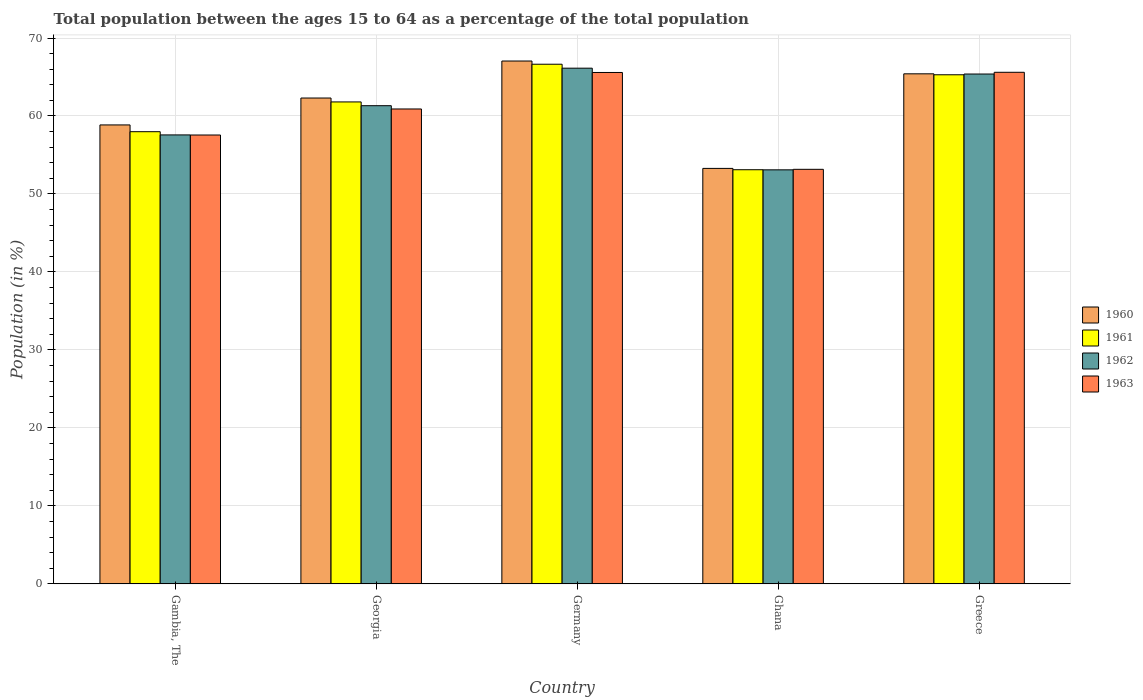How many groups of bars are there?
Your answer should be very brief. 5. How many bars are there on the 2nd tick from the left?
Offer a very short reply. 4. How many bars are there on the 3rd tick from the right?
Provide a short and direct response. 4. What is the label of the 1st group of bars from the left?
Make the answer very short. Gambia, The. In how many cases, is the number of bars for a given country not equal to the number of legend labels?
Give a very brief answer. 0. What is the percentage of the population ages 15 to 64 in 1963 in Greece?
Give a very brief answer. 65.61. Across all countries, what is the maximum percentage of the population ages 15 to 64 in 1963?
Make the answer very short. 65.61. Across all countries, what is the minimum percentage of the population ages 15 to 64 in 1960?
Keep it short and to the point. 53.28. In which country was the percentage of the population ages 15 to 64 in 1962 minimum?
Keep it short and to the point. Ghana. What is the total percentage of the population ages 15 to 64 in 1963 in the graph?
Ensure brevity in your answer.  302.81. What is the difference between the percentage of the population ages 15 to 64 in 1962 in Ghana and that in Greece?
Your response must be concise. -12.29. What is the difference between the percentage of the population ages 15 to 64 in 1962 in Georgia and the percentage of the population ages 15 to 64 in 1963 in Germany?
Make the answer very short. -4.26. What is the average percentage of the population ages 15 to 64 in 1963 per country?
Keep it short and to the point. 60.56. What is the difference between the percentage of the population ages 15 to 64 of/in 1961 and percentage of the population ages 15 to 64 of/in 1963 in Greece?
Give a very brief answer. -0.32. In how many countries, is the percentage of the population ages 15 to 64 in 1962 greater than 48?
Your response must be concise. 5. What is the ratio of the percentage of the population ages 15 to 64 in 1960 in Ghana to that in Greece?
Keep it short and to the point. 0.81. Is the difference between the percentage of the population ages 15 to 64 in 1961 in Gambia, The and Greece greater than the difference between the percentage of the population ages 15 to 64 in 1963 in Gambia, The and Greece?
Provide a succinct answer. Yes. What is the difference between the highest and the second highest percentage of the population ages 15 to 64 in 1962?
Ensure brevity in your answer.  -0.75. What is the difference between the highest and the lowest percentage of the population ages 15 to 64 in 1960?
Your answer should be very brief. 13.77. Is it the case that in every country, the sum of the percentage of the population ages 15 to 64 in 1961 and percentage of the population ages 15 to 64 in 1960 is greater than the sum of percentage of the population ages 15 to 64 in 1963 and percentage of the population ages 15 to 64 in 1962?
Give a very brief answer. No. Are all the bars in the graph horizontal?
Offer a terse response. No. What is the difference between two consecutive major ticks on the Y-axis?
Give a very brief answer. 10. Does the graph contain any zero values?
Your response must be concise. No. Does the graph contain grids?
Provide a short and direct response. Yes. How are the legend labels stacked?
Your response must be concise. Vertical. What is the title of the graph?
Ensure brevity in your answer.  Total population between the ages 15 to 64 as a percentage of the total population. What is the Population (in %) in 1960 in Gambia, The?
Give a very brief answer. 58.86. What is the Population (in %) of 1961 in Gambia, The?
Your answer should be very brief. 57.99. What is the Population (in %) of 1962 in Gambia, The?
Your answer should be compact. 57.57. What is the Population (in %) in 1963 in Gambia, The?
Keep it short and to the point. 57.56. What is the Population (in %) of 1960 in Georgia?
Ensure brevity in your answer.  62.31. What is the Population (in %) of 1961 in Georgia?
Your answer should be compact. 61.8. What is the Population (in %) in 1962 in Georgia?
Your answer should be compact. 61.32. What is the Population (in %) of 1963 in Georgia?
Offer a very short reply. 60.9. What is the Population (in %) in 1960 in Germany?
Make the answer very short. 67.05. What is the Population (in %) of 1961 in Germany?
Keep it short and to the point. 66.64. What is the Population (in %) in 1962 in Germany?
Your response must be concise. 66.13. What is the Population (in %) in 1963 in Germany?
Offer a very short reply. 65.58. What is the Population (in %) of 1960 in Ghana?
Offer a very short reply. 53.28. What is the Population (in %) in 1961 in Ghana?
Offer a very short reply. 53.11. What is the Population (in %) of 1962 in Ghana?
Ensure brevity in your answer.  53.1. What is the Population (in %) in 1963 in Ghana?
Offer a terse response. 53.16. What is the Population (in %) of 1960 in Greece?
Provide a short and direct response. 65.41. What is the Population (in %) in 1961 in Greece?
Ensure brevity in your answer.  65.29. What is the Population (in %) in 1962 in Greece?
Offer a terse response. 65.38. What is the Population (in %) of 1963 in Greece?
Keep it short and to the point. 65.61. Across all countries, what is the maximum Population (in %) of 1960?
Make the answer very short. 67.05. Across all countries, what is the maximum Population (in %) of 1961?
Keep it short and to the point. 66.64. Across all countries, what is the maximum Population (in %) of 1962?
Keep it short and to the point. 66.13. Across all countries, what is the maximum Population (in %) of 1963?
Your answer should be very brief. 65.61. Across all countries, what is the minimum Population (in %) of 1960?
Give a very brief answer. 53.28. Across all countries, what is the minimum Population (in %) in 1961?
Ensure brevity in your answer.  53.11. Across all countries, what is the minimum Population (in %) in 1962?
Offer a terse response. 53.1. Across all countries, what is the minimum Population (in %) in 1963?
Provide a short and direct response. 53.16. What is the total Population (in %) in 1960 in the graph?
Offer a very short reply. 306.9. What is the total Population (in %) in 1961 in the graph?
Offer a terse response. 304.83. What is the total Population (in %) in 1962 in the graph?
Keep it short and to the point. 303.51. What is the total Population (in %) in 1963 in the graph?
Your answer should be compact. 302.81. What is the difference between the Population (in %) in 1960 in Gambia, The and that in Georgia?
Offer a very short reply. -3.45. What is the difference between the Population (in %) of 1961 in Gambia, The and that in Georgia?
Your answer should be very brief. -3.82. What is the difference between the Population (in %) in 1962 in Gambia, The and that in Georgia?
Make the answer very short. -3.75. What is the difference between the Population (in %) in 1963 in Gambia, The and that in Georgia?
Your answer should be compact. -3.34. What is the difference between the Population (in %) of 1960 in Gambia, The and that in Germany?
Keep it short and to the point. -8.2. What is the difference between the Population (in %) of 1961 in Gambia, The and that in Germany?
Provide a succinct answer. -8.65. What is the difference between the Population (in %) in 1962 in Gambia, The and that in Germany?
Make the answer very short. -8.56. What is the difference between the Population (in %) in 1963 in Gambia, The and that in Germany?
Provide a succinct answer. -8.02. What is the difference between the Population (in %) in 1960 in Gambia, The and that in Ghana?
Provide a succinct answer. 5.58. What is the difference between the Population (in %) in 1961 in Gambia, The and that in Ghana?
Your response must be concise. 4.88. What is the difference between the Population (in %) of 1962 in Gambia, The and that in Ghana?
Keep it short and to the point. 4.48. What is the difference between the Population (in %) in 1963 in Gambia, The and that in Ghana?
Make the answer very short. 4.4. What is the difference between the Population (in %) of 1960 in Gambia, The and that in Greece?
Your answer should be compact. -6.55. What is the difference between the Population (in %) in 1961 in Gambia, The and that in Greece?
Offer a terse response. -7.3. What is the difference between the Population (in %) in 1962 in Gambia, The and that in Greece?
Ensure brevity in your answer.  -7.81. What is the difference between the Population (in %) in 1963 in Gambia, The and that in Greece?
Provide a short and direct response. -8.04. What is the difference between the Population (in %) in 1960 in Georgia and that in Germany?
Give a very brief answer. -4.74. What is the difference between the Population (in %) in 1961 in Georgia and that in Germany?
Provide a short and direct response. -4.84. What is the difference between the Population (in %) of 1962 in Georgia and that in Germany?
Give a very brief answer. -4.81. What is the difference between the Population (in %) in 1963 in Georgia and that in Germany?
Ensure brevity in your answer.  -4.68. What is the difference between the Population (in %) in 1960 in Georgia and that in Ghana?
Ensure brevity in your answer.  9.03. What is the difference between the Population (in %) of 1961 in Georgia and that in Ghana?
Keep it short and to the point. 8.69. What is the difference between the Population (in %) in 1962 in Georgia and that in Ghana?
Make the answer very short. 8.23. What is the difference between the Population (in %) of 1963 in Georgia and that in Ghana?
Keep it short and to the point. 7.74. What is the difference between the Population (in %) of 1960 in Georgia and that in Greece?
Offer a very short reply. -3.1. What is the difference between the Population (in %) of 1961 in Georgia and that in Greece?
Provide a succinct answer. -3.48. What is the difference between the Population (in %) in 1962 in Georgia and that in Greece?
Give a very brief answer. -4.06. What is the difference between the Population (in %) of 1963 in Georgia and that in Greece?
Give a very brief answer. -4.7. What is the difference between the Population (in %) in 1960 in Germany and that in Ghana?
Make the answer very short. 13.77. What is the difference between the Population (in %) of 1961 in Germany and that in Ghana?
Give a very brief answer. 13.53. What is the difference between the Population (in %) in 1962 in Germany and that in Ghana?
Provide a short and direct response. 13.04. What is the difference between the Population (in %) of 1963 in Germany and that in Ghana?
Provide a succinct answer. 12.42. What is the difference between the Population (in %) of 1960 in Germany and that in Greece?
Ensure brevity in your answer.  1.64. What is the difference between the Population (in %) in 1961 in Germany and that in Greece?
Keep it short and to the point. 1.35. What is the difference between the Population (in %) of 1962 in Germany and that in Greece?
Ensure brevity in your answer.  0.75. What is the difference between the Population (in %) in 1963 in Germany and that in Greece?
Give a very brief answer. -0.02. What is the difference between the Population (in %) of 1960 in Ghana and that in Greece?
Offer a very short reply. -12.13. What is the difference between the Population (in %) of 1961 in Ghana and that in Greece?
Ensure brevity in your answer.  -12.18. What is the difference between the Population (in %) in 1962 in Ghana and that in Greece?
Your response must be concise. -12.29. What is the difference between the Population (in %) in 1963 in Ghana and that in Greece?
Offer a terse response. -12.44. What is the difference between the Population (in %) in 1960 in Gambia, The and the Population (in %) in 1961 in Georgia?
Your response must be concise. -2.95. What is the difference between the Population (in %) in 1960 in Gambia, The and the Population (in %) in 1962 in Georgia?
Provide a short and direct response. -2.47. What is the difference between the Population (in %) of 1960 in Gambia, The and the Population (in %) of 1963 in Georgia?
Make the answer very short. -2.05. What is the difference between the Population (in %) in 1961 in Gambia, The and the Population (in %) in 1962 in Georgia?
Provide a succinct answer. -3.33. What is the difference between the Population (in %) of 1961 in Gambia, The and the Population (in %) of 1963 in Georgia?
Offer a very short reply. -2.91. What is the difference between the Population (in %) of 1962 in Gambia, The and the Population (in %) of 1963 in Georgia?
Your answer should be compact. -3.33. What is the difference between the Population (in %) in 1960 in Gambia, The and the Population (in %) in 1961 in Germany?
Your response must be concise. -7.78. What is the difference between the Population (in %) in 1960 in Gambia, The and the Population (in %) in 1962 in Germany?
Give a very brief answer. -7.28. What is the difference between the Population (in %) in 1960 in Gambia, The and the Population (in %) in 1963 in Germany?
Ensure brevity in your answer.  -6.73. What is the difference between the Population (in %) in 1961 in Gambia, The and the Population (in %) in 1962 in Germany?
Keep it short and to the point. -8.15. What is the difference between the Population (in %) of 1961 in Gambia, The and the Population (in %) of 1963 in Germany?
Provide a succinct answer. -7.59. What is the difference between the Population (in %) of 1962 in Gambia, The and the Population (in %) of 1963 in Germany?
Offer a very short reply. -8.01. What is the difference between the Population (in %) in 1960 in Gambia, The and the Population (in %) in 1961 in Ghana?
Give a very brief answer. 5.75. What is the difference between the Population (in %) in 1960 in Gambia, The and the Population (in %) in 1962 in Ghana?
Provide a succinct answer. 5.76. What is the difference between the Population (in %) in 1960 in Gambia, The and the Population (in %) in 1963 in Ghana?
Provide a succinct answer. 5.69. What is the difference between the Population (in %) in 1961 in Gambia, The and the Population (in %) in 1962 in Ghana?
Make the answer very short. 4.89. What is the difference between the Population (in %) in 1961 in Gambia, The and the Population (in %) in 1963 in Ghana?
Your answer should be compact. 4.83. What is the difference between the Population (in %) of 1962 in Gambia, The and the Population (in %) of 1963 in Ghana?
Provide a short and direct response. 4.41. What is the difference between the Population (in %) in 1960 in Gambia, The and the Population (in %) in 1961 in Greece?
Ensure brevity in your answer.  -6.43. What is the difference between the Population (in %) in 1960 in Gambia, The and the Population (in %) in 1962 in Greece?
Give a very brief answer. -6.53. What is the difference between the Population (in %) of 1960 in Gambia, The and the Population (in %) of 1963 in Greece?
Offer a very short reply. -6.75. What is the difference between the Population (in %) of 1961 in Gambia, The and the Population (in %) of 1962 in Greece?
Keep it short and to the point. -7.39. What is the difference between the Population (in %) of 1961 in Gambia, The and the Population (in %) of 1963 in Greece?
Offer a very short reply. -7.62. What is the difference between the Population (in %) in 1962 in Gambia, The and the Population (in %) in 1963 in Greece?
Ensure brevity in your answer.  -8.03. What is the difference between the Population (in %) in 1960 in Georgia and the Population (in %) in 1961 in Germany?
Offer a very short reply. -4.33. What is the difference between the Population (in %) in 1960 in Georgia and the Population (in %) in 1962 in Germany?
Your answer should be very brief. -3.83. What is the difference between the Population (in %) of 1960 in Georgia and the Population (in %) of 1963 in Germany?
Keep it short and to the point. -3.28. What is the difference between the Population (in %) in 1961 in Georgia and the Population (in %) in 1962 in Germany?
Give a very brief answer. -4.33. What is the difference between the Population (in %) in 1961 in Georgia and the Population (in %) in 1963 in Germany?
Your answer should be very brief. -3.78. What is the difference between the Population (in %) of 1962 in Georgia and the Population (in %) of 1963 in Germany?
Your answer should be very brief. -4.26. What is the difference between the Population (in %) of 1960 in Georgia and the Population (in %) of 1961 in Ghana?
Offer a very short reply. 9.2. What is the difference between the Population (in %) of 1960 in Georgia and the Population (in %) of 1962 in Ghana?
Provide a short and direct response. 9.21. What is the difference between the Population (in %) in 1960 in Georgia and the Population (in %) in 1963 in Ghana?
Your answer should be compact. 9.15. What is the difference between the Population (in %) in 1961 in Georgia and the Population (in %) in 1962 in Ghana?
Your response must be concise. 8.71. What is the difference between the Population (in %) of 1961 in Georgia and the Population (in %) of 1963 in Ghana?
Keep it short and to the point. 8.64. What is the difference between the Population (in %) of 1962 in Georgia and the Population (in %) of 1963 in Ghana?
Offer a very short reply. 8.16. What is the difference between the Population (in %) of 1960 in Georgia and the Population (in %) of 1961 in Greece?
Offer a terse response. -2.98. What is the difference between the Population (in %) of 1960 in Georgia and the Population (in %) of 1962 in Greece?
Provide a short and direct response. -3.08. What is the difference between the Population (in %) in 1960 in Georgia and the Population (in %) in 1963 in Greece?
Your response must be concise. -3.3. What is the difference between the Population (in %) of 1961 in Georgia and the Population (in %) of 1962 in Greece?
Provide a short and direct response. -3.58. What is the difference between the Population (in %) of 1961 in Georgia and the Population (in %) of 1963 in Greece?
Offer a terse response. -3.8. What is the difference between the Population (in %) of 1962 in Georgia and the Population (in %) of 1963 in Greece?
Provide a short and direct response. -4.28. What is the difference between the Population (in %) of 1960 in Germany and the Population (in %) of 1961 in Ghana?
Provide a succinct answer. 13.94. What is the difference between the Population (in %) of 1960 in Germany and the Population (in %) of 1962 in Ghana?
Offer a terse response. 13.95. What is the difference between the Population (in %) of 1960 in Germany and the Population (in %) of 1963 in Ghana?
Provide a succinct answer. 13.89. What is the difference between the Population (in %) in 1961 in Germany and the Population (in %) in 1962 in Ghana?
Your answer should be compact. 13.54. What is the difference between the Population (in %) in 1961 in Germany and the Population (in %) in 1963 in Ghana?
Keep it short and to the point. 13.48. What is the difference between the Population (in %) of 1962 in Germany and the Population (in %) of 1963 in Ghana?
Ensure brevity in your answer.  12.97. What is the difference between the Population (in %) in 1960 in Germany and the Population (in %) in 1961 in Greece?
Keep it short and to the point. 1.76. What is the difference between the Population (in %) in 1960 in Germany and the Population (in %) in 1962 in Greece?
Offer a very short reply. 1.67. What is the difference between the Population (in %) in 1960 in Germany and the Population (in %) in 1963 in Greece?
Keep it short and to the point. 1.45. What is the difference between the Population (in %) of 1961 in Germany and the Population (in %) of 1962 in Greece?
Offer a terse response. 1.26. What is the difference between the Population (in %) of 1961 in Germany and the Population (in %) of 1963 in Greece?
Make the answer very short. 1.03. What is the difference between the Population (in %) in 1962 in Germany and the Population (in %) in 1963 in Greece?
Your response must be concise. 0.53. What is the difference between the Population (in %) of 1960 in Ghana and the Population (in %) of 1961 in Greece?
Ensure brevity in your answer.  -12.01. What is the difference between the Population (in %) of 1960 in Ghana and the Population (in %) of 1962 in Greece?
Make the answer very short. -12.1. What is the difference between the Population (in %) of 1960 in Ghana and the Population (in %) of 1963 in Greece?
Provide a short and direct response. -12.33. What is the difference between the Population (in %) in 1961 in Ghana and the Population (in %) in 1962 in Greece?
Your answer should be compact. -12.27. What is the difference between the Population (in %) of 1961 in Ghana and the Population (in %) of 1963 in Greece?
Offer a terse response. -12.5. What is the difference between the Population (in %) in 1962 in Ghana and the Population (in %) in 1963 in Greece?
Offer a terse response. -12.51. What is the average Population (in %) in 1960 per country?
Ensure brevity in your answer.  61.38. What is the average Population (in %) of 1961 per country?
Your response must be concise. 60.97. What is the average Population (in %) in 1962 per country?
Provide a short and direct response. 60.7. What is the average Population (in %) in 1963 per country?
Your response must be concise. 60.56. What is the difference between the Population (in %) of 1960 and Population (in %) of 1961 in Gambia, The?
Your answer should be compact. 0.87. What is the difference between the Population (in %) in 1960 and Population (in %) in 1962 in Gambia, The?
Your answer should be very brief. 1.28. What is the difference between the Population (in %) of 1960 and Population (in %) of 1963 in Gambia, The?
Provide a succinct answer. 1.29. What is the difference between the Population (in %) in 1961 and Population (in %) in 1962 in Gambia, The?
Your response must be concise. 0.41. What is the difference between the Population (in %) of 1961 and Population (in %) of 1963 in Gambia, The?
Your response must be concise. 0.43. What is the difference between the Population (in %) of 1962 and Population (in %) of 1963 in Gambia, The?
Your response must be concise. 0.01. What is the difference between the Population (in %) in 1960 and Population (in %) in 1961 in Georgia?
Your answer should be compact. 0.5. What is the difference between the Population (in %) in 1960 and Population (in %) in 1962 in Georgia?
Offer a terse response. 0.98. What is the difference between the Population (in %) in 1960 and Population (in %) in 1963 in Georgia?
Offer a very short reply. 1.4. What is the difference between the Population (in %) in 1961 and Population (in %) in 1962 in Georgia?
Keep it short and to the point. 0.48. What is the difference between the Population (in %) of 1961 and Population (in %) of 1963 in Georgia?
Make the answer very short. 0.9. What is the difference between the Population (in %) of 1962 and Population (in %) of 1963 in Georgia?
Provide a succinct answer. 0.42. What is the difference between the Population (in %) in 1960 and Population (in %) in 1961 in Germany?
Keep it short and to the point. 0.41. What is the difference between the Population (in %) of 1960 and Population (in %) of 1962 in Germany?
Offer a very short reply. 0.92. What is the difference between the Population (in %) of 1960 and Population (in %) of 1963 in Germany?
Give a very brief answer. 1.47. What is the difference between the Population (in %) of 1961 and Population (in %) of 1962 in Germany?
Make the answer very short. 0.51. What is the difference between the Population (in %) of 1961 and Population (in %) of 1963 in Germany?
Your answer should be compact. 1.06. What is the difference between the Population (in %) of 1962 and Population (in %) of 1963 in Germany?
Provide a short and direct response. 0.55. What is the difference between the Population (in %) in 1960 and Population (in %) in 1961 in Ghana?
Provide a succinct answer. 0.17. What is the difference between the Population (in %) in 1960 and Population (in %) in 1962 in Ghana?
Provide a succinct answer. 0.18. What is the difference between the Population (in %) in 1960 and Population (in %) in 1963 in Ghana?
Keep it short and to the point. 0.12. What is the difference between the Population (in %) in 1961 and Population (in %) in 1962 in Ghana?
Offer a terse response. 0.01. What is the difference between the Population (in %) in 1961 and Population (in %) in 1963 in Ghana?
Your response must be concise. -0.05. What is the difference between the Population (in %) in 1962 and Population (in %) in 1963 in Ghana?
Your answer should be compact. -0.06. What is the difference between the Population (in %) in 1960 and Population (in %) in 1961 in Greece?
Your response must be concise. 0.12. What is the difference between the Population (in %) in 1960 and Population (in %) in 1962 in Greece?
Provide a short and direct response. 0.03. What is the difference between the Population (in %) in 1960 and Population (in %) in 1963 in Greece?
Make the answer very short. -0.2. What is the difference between the Population (in %) in 1961 and Population (in %) in 1962 in Greece?
Keep it short and to the point. -0.1. What is the difference between the Population (in %) of 1961 and Population (in %) of 1963 in Greece?
Give a very brief answer. -0.32. What is the difference between the Population (in %) in 1962 and Population (in %) in 1963 in Greece?
Provide a succinct answer. -0.22. What is the ratio of the Population (in %) of 1960 in Gambia, The to that in Georgia?
Your answer should be very brief. 0.94. What is the ratio of the Population (in %) of 1961 in Gambia, The to that in Georgia?
Offer a terse response. 0.94. What is the ratio of the Population (in %) in 1962 in Gambia, The to that in Georgia?
Offer a terse response. 0.94. What is the ratio of the Population (in %) of 1963 in Gambia, The to that in Georgia?
Provide a short and direct response. 0.95. What is the ratio of the Population (in %) in 1960 in Gambia, The to that in Germany?
Give a very brief answer. 0.88. What is the ratio of the Population (in %) in 1961 in Gambia, The to that in Germany?
Make the answer very short. 0.87. What is the ratio of the Population (in %) of 1962 in Gambia, The to that in Germany?
Offer a terse response. 0.87. What is the ratio of the Population (in %) of 1963 in Gambia, The to that in Germany?
Provide a succinct answer. 0.88. What is the ratio of the Population (in %) of 1960 in Gambia, The to that in Ghana?
Provide a short and direct response. 1.1. What is the ratio of the Population (in %) of 1961 in Gambia, The to that in Ghana?
Your answer should be compact. 1.09. What is the ratio of the Population (in %) in 1962 in Gambia, The to that in Ghana?
Offer a terse response. 1.08. What is the ratio of the Population (in %) in 1963 in Gambia, The to that in Ghana?
Your answer should be very brief. 1.08. What is the ratio of the Population (in %) in 1960 in Gambia, The to that in Greece?
Provide a short and direct response. 0.9. What is the ratio of the Population (in %) of 1961 in Gambia, The to that in Greece?
Keep it short and to the point. 0.89. What is the ratio of the Population (in %) of 1962 in Gambia, The to that in Greece?
Offer a terse response. 0.88. What is the ratio of the Population (in %) in 1963 in Gambia, The to that in Greece?
Your answer should be very brief. 0.88. What is the ratio of the Population (in %) of 1960 in Georgia to that in Germany?
Give a very brief answer. 0.93. What is the ratio of the Population (in %) of 1961 in Georgia to that in Germany?
Provide a short and direct response. 0.93. What is the ratio of the Population (in %) of 1962 in Georgia to that in Germany?
Make the answer very short. 0.93. What is the ratio of the Population (in %) of 1960 in Georgia to that in Ghana?
Provide a short and direct response. 1.17. What is the ratio of the Population (in %) in 1961 in Georgia to that in Ghana?
Make the answer very short. 1.16. What is the ratio of the Population (in %) in 1962 in Georgia to that in Ghana?
Your answer should be compact. 1.15. What is the ratio of the Population (in %) of 1963 in Georgia to that in Ghana?
Your answer should be very brief. 1.15. What is the ratio of the Population (in %) of 1960 in Georgia to that in Greece?
Provide a succinct answer. 0.95. What is the ratio of the Population (in %) of 1961 in Georgia to that in Greece?
Provide a short and direct response. 0.95. What is the ratio of the Population (in %) in 1962 in Georgia to that in Greece?
Your answer should be compact. 0.94. What is the ratio of the Population (in %) of 1963 in Georgia to that in Greece?
Ensure brevity in your answer.  0.93. What is the ratio of the Population (in %) in 1960 in Germany to that in Ghana?
Your answer should be very brief. 1.26. What is the ratio of the Population (in %) of 1961 in Germany to that in Ghana?
Ensure brevity in your answer.  1.25. What is the ratio of the Population (in %) of 1962 in Germany to that in Ghana?
Your response must be concise. 1.25. What is the ratio of the Population (in %) in 1963 in Germany to that in Ghana?
Your response must be concise. 1.23. What is the ratio of the Population (in %) in 1960 in Germany to that in Greece?
Offer a terse response. 1.03. What is the ratio of the Population (in %) of 1961 in Germany to that in Greece?
Your response must be concise. 1.02. What is the ratio of the Population (in %) in 1962 in Germany to that in Greece?
Ensure brevity in your answer.  1.01. What is the ratio of the Population (in %) of 1960 in Ghana to that in Greece?
Your answer should be compact. 0.81. What is the ratio of the Population (in %) of 1961 in Ghana to that in Greece?
Offer a very short reply. 0.81. What is the ratio of the Population (in %) in 1962 in Ghana to that in Greece?
Offer a very short reply. 0.81. What is the ratio of the Population (in %) of 1963 in Ghana to that in Greece?
Ensure brevity in your answer.  0.81. What is the difference between the highest and the second highest Population (in %) of 1960?
Provide a succinct answer. 1.64. What is the difference between the highest and the second highest Population (in %) of 1961?
Offer a very short reply. 1.35. What is the difference between the highest and the second highest Population (in %) of 1962?
Provide a short and direct response. 0.75. What is the difference between the highest and the second highest Population (in %) of 1963?
Your response must be concise. 0.02. What is the difference between the highest and the lowest Population (in %) of 1960?
Your answer should be compact. 13.77. What is the difference between the highest and the lowest Population (in %) of 1961?
Your answer should be compact. 13.53. What is the difference between the highest and the lowest Population (in %) of 1962?
Give a very brief answer. 13.04. What is the difference between the highest and the lowest Population (in %) in 1963?
Give a very brief answer. 12.44. 